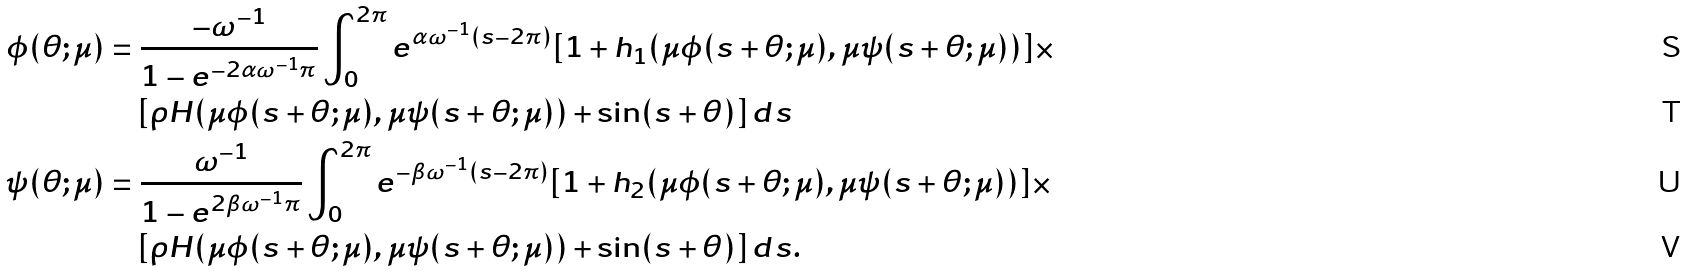<formula> <loc_0><loc_0><loc_500><loc_500>\phi ( \theta ; \mu ) & = \frac { - \omega ^ { - 1 } } { 1 - e ^ { - 2 \alpha \omega ^ { - 1 } \pi } } \int _ { 0 } ^ { 2 \pi } e ^ { \alpha \omega ^ { - 1 } ( s - 2 \pi ) } [ 1 + h _ { 1 } ( \mu \phi ( s + \theta ; \mu ) , \mu \psi ( s + \theta ; \mu ) ) ] \times \\ & \quad [ \rho H ( \mu \phi ( s + \theta ; \mu ) , \mu \psi ( s + \theta ; \mu ) ) + \sin ( s + \theta ) ] \, d s \\ \psi ( \theta ; \mu ) & = \frac { \omega ^ { - 1 } } { 1 - e ^ { 2 \beta \omega ^ { - 1 } \pi } } \int _ { 0 } ^ { 2 \pi } e ^ { - \beta \omega ^ { - 1 } ( s - 2 \pi ) } [ 1 + h _ { 2 } ( \mu \phi ( s + \theta ; \mu ) , \mu \psi ( s + \theta ; \mu ) ) ] \times \\ & \quad [ \rho H ( \mu \phi ( s + \theta ; \mu ) , \mu \psi ( s + \theta ; \mu ) ) + \sin ( s + \theta ) ] \, d s .</formula> 